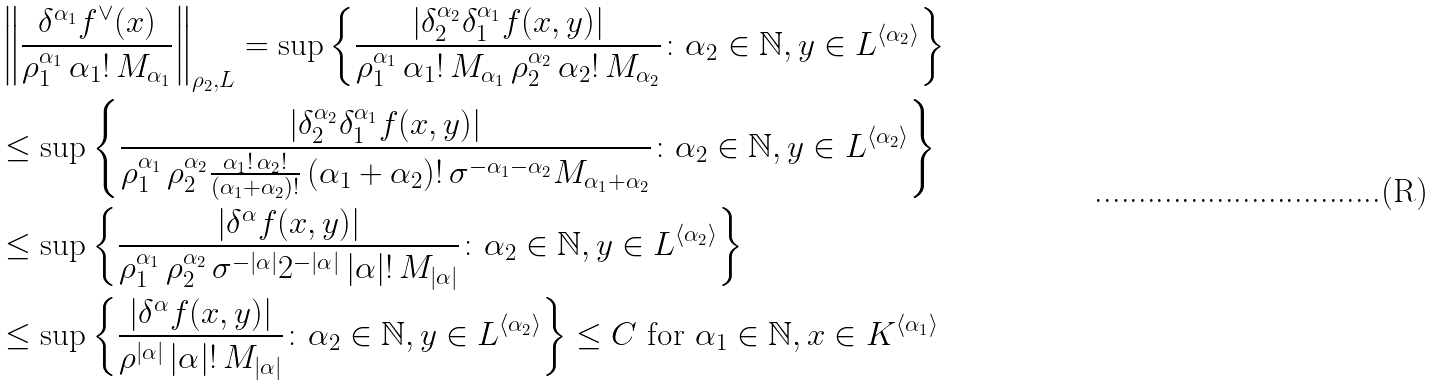Convert formula to latex. <formula><loc_0><loc_0><loc_500><loc_500>& \left \| \frac { \delta ^ { \alpha _ { 1 } } f ^ { \vee } ( x ) } { \rho _ { 1 } ^ { \alpha _ { 1 } } \, \alpha _ { 1 } ! \, M _ { \alpha _ { 1 } } } \right \| _ { \rho _ { 2 } , L } = \sup \left \{ \frac { | \delta _ { 2 } ^ { \alpha _ { 2 } } \delta _ { 1 } ^ { \alpha _ { 1 } } f ( x , y ) | } { \rho _ { 1 } ^ { \alpha _ { 1 } } \, \alpha _ { 1 } ! \, M _ { \alpha _ { 1 } } \, \rho _ { 2 } ^ { \alpha _ { 2 } } \, \alpha _ { 2 } ! \, M _ { \alpha _ { 2 } } } \colon \alpha _ { 2 } \in \mathbb { N } , y \in L ^ { \langle \alpha _ { 2 } \rangle } \right \} \\ & \leq \sup \left \{ \frac { | \delta _ { 2 } ^ { \alpha _ { 2 } } \delta _ { 1 } ^ { \alpha _ { 1 } } f ( x , y ) | } { \rho _ { 1 } ^ { \alpha _ { 1 } } \, \rho _ { 2 } ^ { \alpha _ { 2 } } \frac { \alpha _ { 1 } ! \, \alpha _ { 2 } ! } { ( \alpha _ { 1 } + \alpha _ { 2 } ) ! } \, ( \alpha _ { 1 } + \alpha _ { 2 } ) ! \, \sigma ^ { - \alpha _ { 1 } - \alpha _ { 2 } } M _ { \alpha _ { 1 } + \alpha _ { 2 } } } \colon \alpha _ { 2 } \in \mathbb { N } , y \in L ^ { \langle \alpha _ { 2 } \rangle } \right \} \\ & \leq \sup \left \{ \frac { | \delta ^ { \alpha } f ( x , y ) | } { \rho _ { 1 } ^ { \alpha _ { 1 } } \, \rho _ { 2 } ^ { \alpha _ { 2 } } \, \sigma ^ { - | \alpha | } 2 ^ { - | \alpha | } \, | \alpha | ! \, M _ { | \alpha | } } \colon \alpha _ { 2 } \in \mathbb { N } , y \in L ^ { \langle \alpha _ { 2 } \rangle } \right \} \\ & \leq \sup \left \{ \frac { | \delta ^ { \alpha } f ( x , y ) | } { \rho ^ { | \alpha | } \, | \alpha | ! \, M _ { | \alpha | } } \colon \alpha _ { 2 } \in \mathbb { N } , y \in L ^ { \langle \alpha _ { 2 } \rangle } \right \} \leq C \text { for } \alpha _ { 1 } \in \mathbb { N } , x \in K ^ { \langle \alpha _ { 1 } \rangle }</formula> 